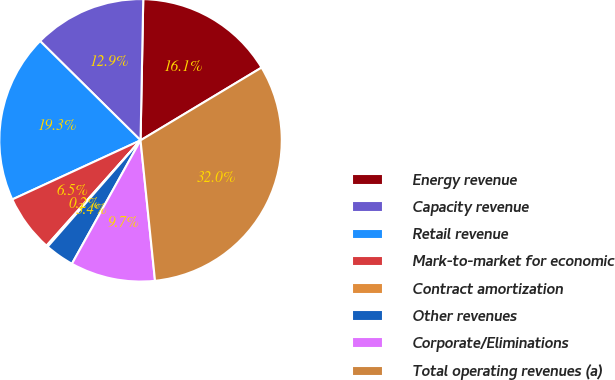Convert chart. <chart><loc_0><loc_0><loc_500><loc_500><pie_chart><fcel>Energy revenue<fcel>Capacity revenue<fcel>Retail revenue<fcel>Mark-to-market for economic<fcel>Contract amortization<fcel>Other revenues<fcel>Corporate/Eliminations<fcel>Total operating revenues (a)<nl><fcel>16.08%<fcel>12.9%<fcel>19.28%<fcel>6.53%<fcel>0.17%<fcel>3.35%<fcel>9.71%<fcel>31.98%<nl></chart> 